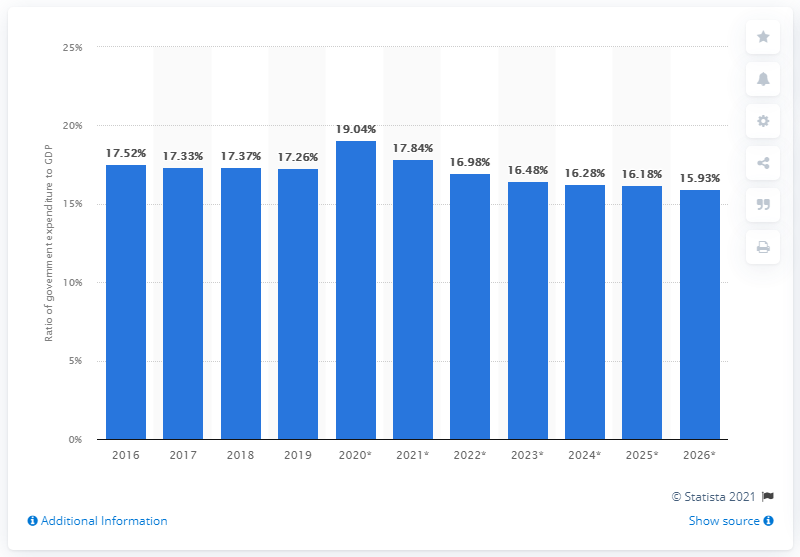Outline some significant characteristics in this image. In 2019, government expenditure accounted for 17.26% of Taiwan's gross domestic product. 